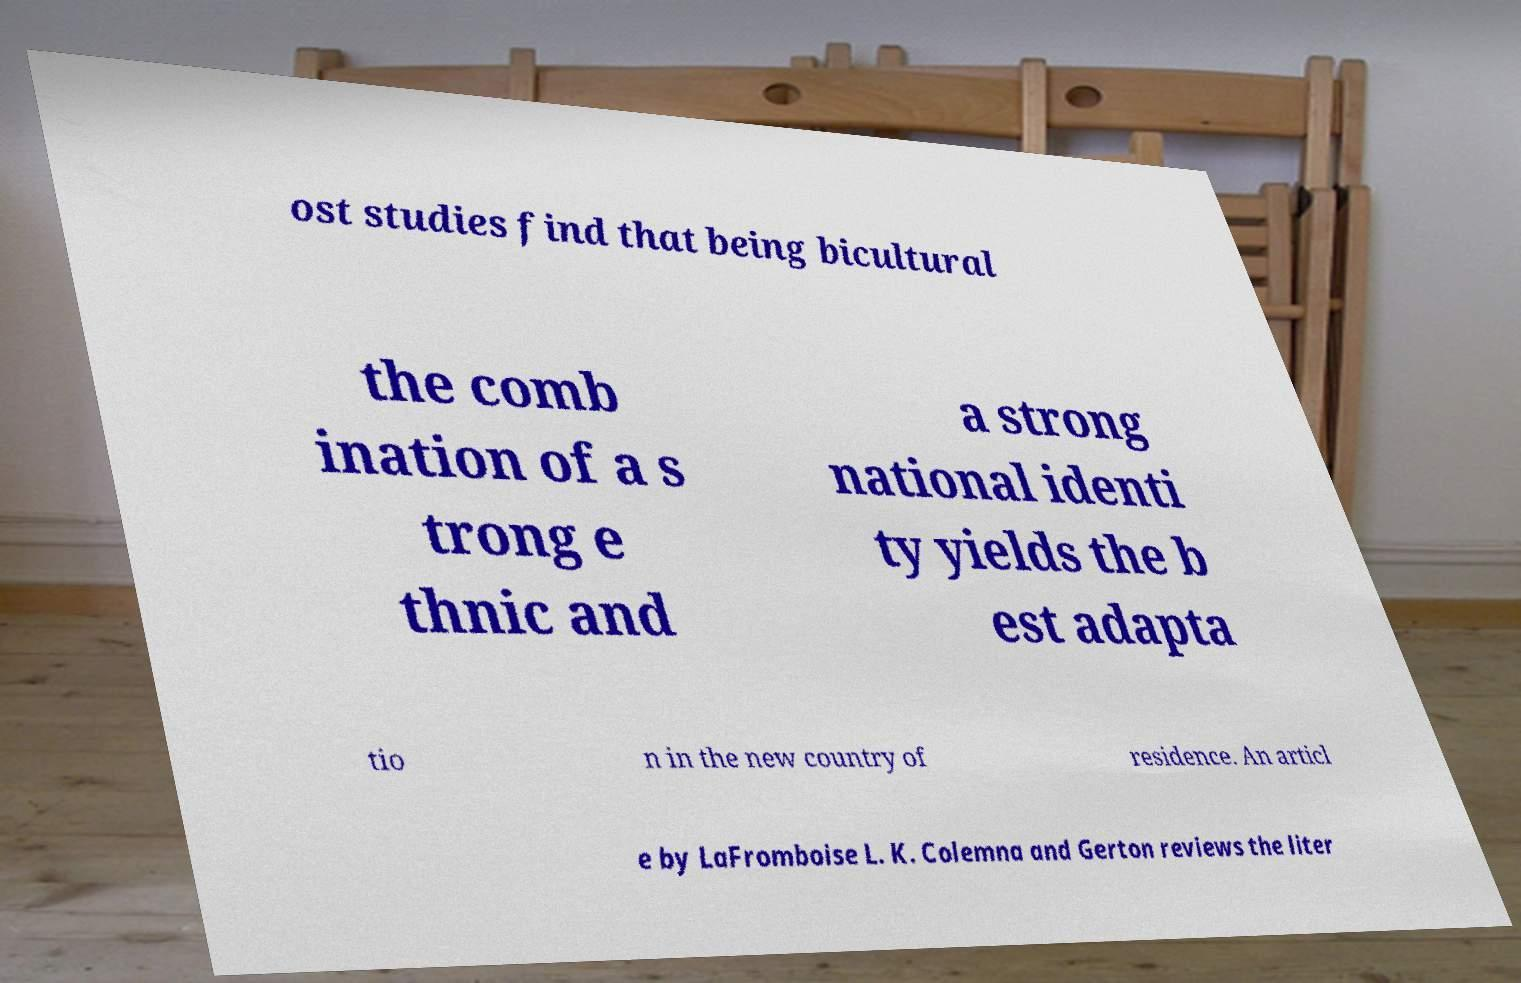Please identify and transcribe the text found in this image. ost studies find that being bicultural the comb ination of a s trong e thnic and a strong national identi ty yields the b est adapta tio n in the new country of residence. An articl e by LaFromboise L. K. Colemna and Gerton reviews the liter 